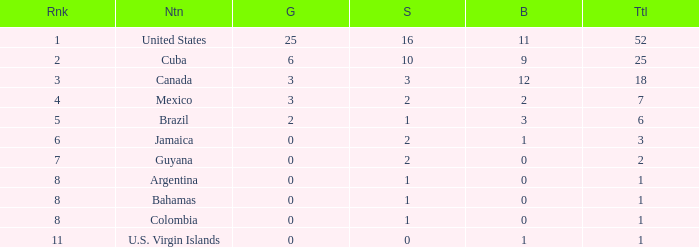What is the fewest number of silver medals a nation who ranked below 8 received? 0.0. 